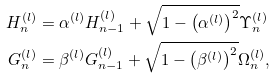<formula> <loc_0><loc_0><loc_500><loc_500>H ^ { ( l ) } _ { n } & = \alpha ^ { ( l ) } H ^ { ( l ) } _ { n - 1 } + \sqrt { 1 - \left ( \alpha ^ { ( l ) } \right ) ^ { 2 } } \Upsilon ^ { ( l ) } _ { n } \\ G ^ { ( l ) } _ { n } & = \beta ^ { ( l ) } G ^ { ( l ) } _ { n - 1 } + \sqrt { 1 - \left ( \beta ^ { ( l ) } \right ) ^ { 2 } } \Omega ^ { ( l ) } _ { n } ,</formula> 